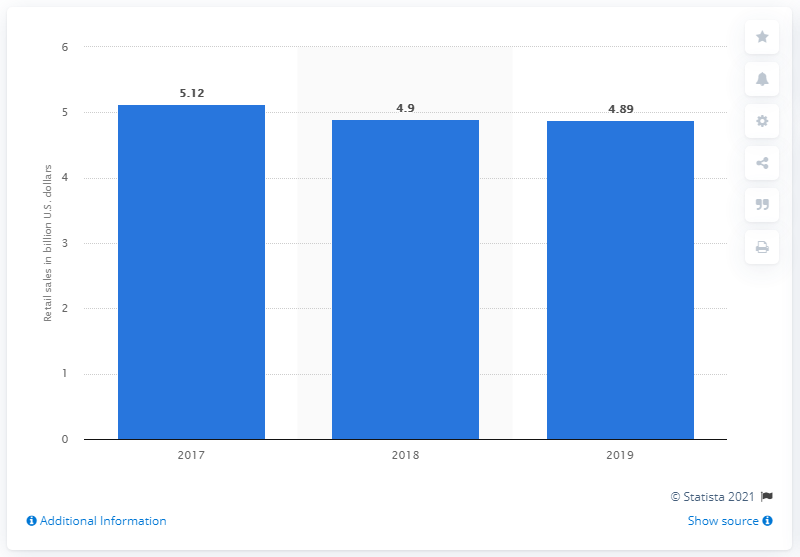Point out several critical features in this image. According to data from 2019, Saks Fifth Avenue's retail sales totaled approximately 4.89 billion dollars. 